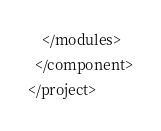Convert code to text. <code><loc_0><loc_0><loc_500><loc_500><_XML_>    </modules>
  </component>
</project></code> 